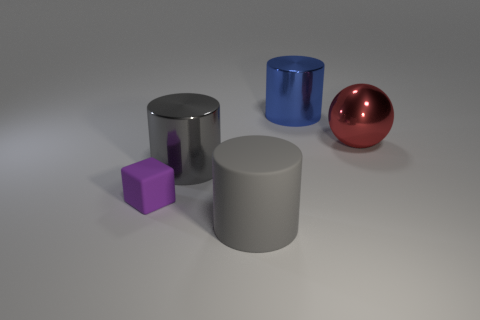Is there a purple matte object that has the same size as the gray rubber object?
Give a very brief answer. No. Is the number of red metal balls that are in front of the purple object greater than the number of tiny purple things?
Provide a short and direct response. No. How many big objects are either red objects or blue shiny blocks?
Your response must be concise. 1. How many big matte objects have the same shape as the small purple rubber object?
Ensure brevity in your answer.  0. The small purple object that is behind the thing that is in front of the tiny cube is made of what material?
Offer a very short reply. Rubber. There is a object left of the big gray metallic thing; what is its size?
Offer a very short reply. Small. What number of gray objects are either big matte things or cylinders?
Ensure brevity in your answer.  2. There is another gray thing that is the same shape as the gray metal object; what material is it?
Your answer should be compact. Rubber. Is the number of small blocks behind the big red metallic sphere the same as the number of big red blocks?
Provide a succinct answer. Yes. There is a thing that is both on the left side of the large gray matte thing and on the right side of the tiny thing; how big is it?
Make the answer very short. Large. 